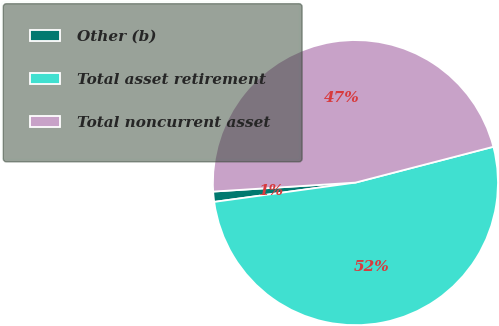Convert chart to OTSL. <chart><loc_0><loc_0><loc_500><loc_500><pie_chart><fcel>Other (b)<fcel>Total asset retirement<fcel>Total noncurrent asset<nl><fcel>1.16%<fcel>51.88%<fcel>46.95%<nl></chart> 